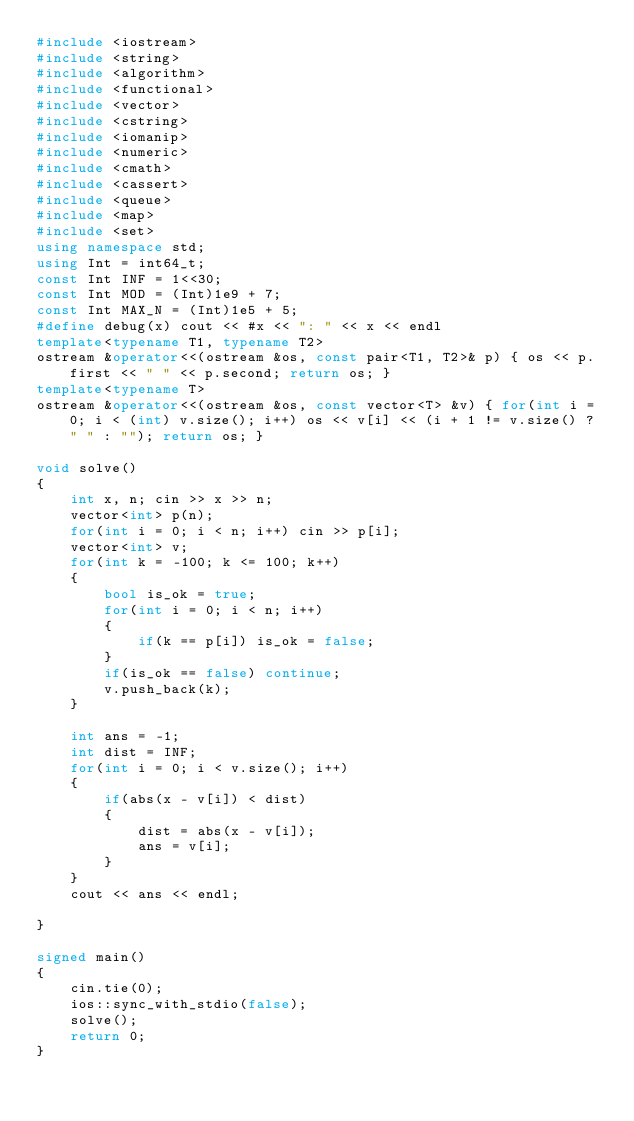Convert code to text. <code><loc_0><loc_0><loc_500><loc_500><_C++_>#include <iostream>
#include <string>
#include <algorithm>
#include <functional>
#include <vector>
#include <cstring>
#include <iomanip>
#include <numeric>
#include <cmath>
#include <cassert>
#include <queue>
#include <map>
#include <set>
using namespace std;
using Int = int64_t;
const Int INF = 1<<30;
const Int MOD = (Int)1e9 + 7;
const Int MAX_N = (Int)1e5 + 5;
#define debug(x) cout << #x << ": " << x << endl
template<typename T1, typename T2>
ostream &operator<<(ostream &os, const pair<T1, T2>& p) { os << p.first << " " << p.second; return os; }
template<typename T>
ostream &operator<<(ostream &os, const vector<T> &v) { for(int i = 0; i < (int) v.size(); i++) os << v[i] << (i + 1 != v.size() ? " " : ""); return os; }

void solve()
{
    int x, n; cin >> x >> n;
    vector<int> p(n);
    for(int i = 0; i < n; i++) cin >> p[i];
    vector<int> v;
    for(int k = -100; k <= 100; k++)
    {
        bool is_ok = true;
        for(int i = 0; i < n; i++)
        {
            if(k == p[i]) is_ok = false;
        }
        if(is_ok == false) continue;
        v.push_back(k);
    }

    int ans = -1;
    int dist = INF;
    for(int i = 0; i < v.size(); i++)
    {
        if(abs(x - v[i]) < dist)
        {
            dist = abs(x - v[i]);
            ans = v[i];
        }
    }
    cout << ans << endl;

}

signed main()
{
    cin.tie(0);
    ios::sync_with_stdio(false);
    solve();
    return 0;
}</code> 